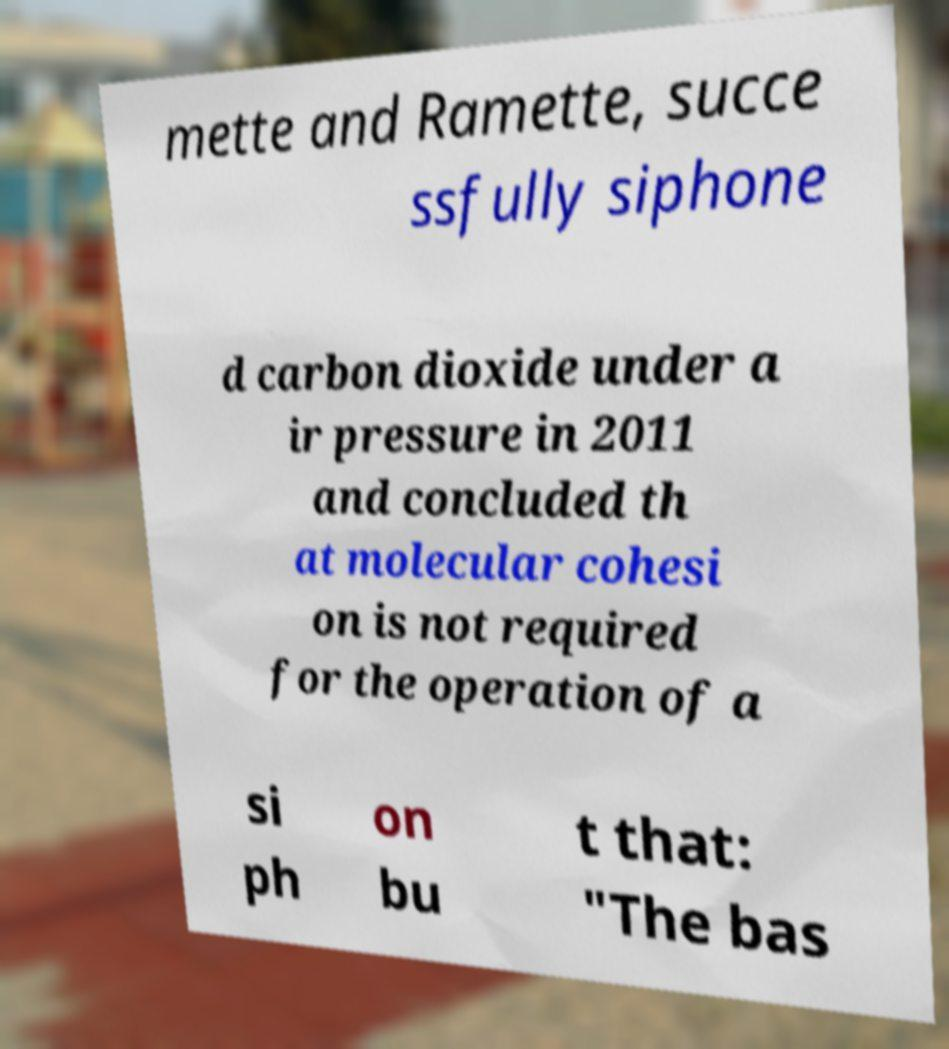Please identify and transcribe the text found in this image. mette and Ramette, succe ssfully siphone d carbon dioxide under a ir pressure in 2011 and concluded th at molecular cohesi on is not required for the operation of a si ph on bu t that: "The bas 